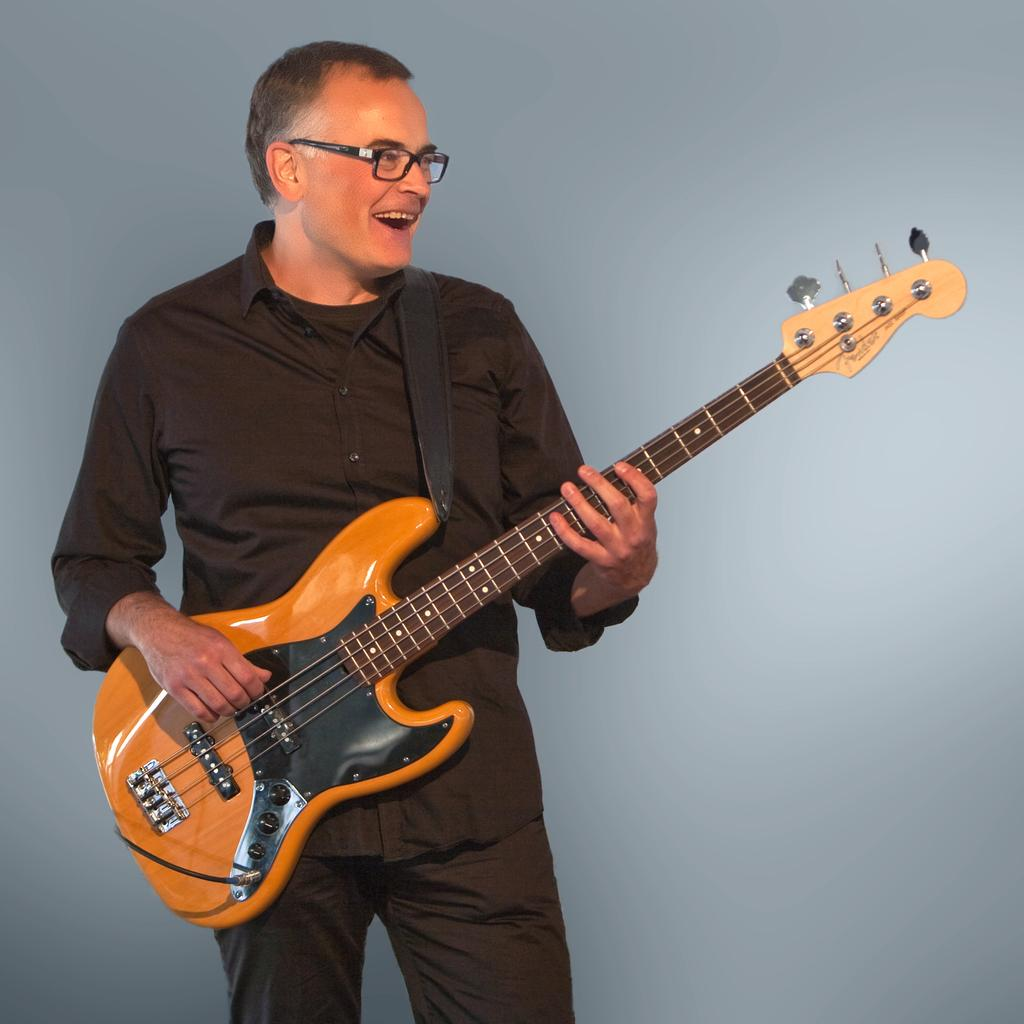What is the man in the image doing? The man is playing a guitar in the image. What is the man wearing? The man is wearing a black dress in the image. What color can be seen in the background of the image? There is a blue color in the background of the image. Can you see any oranges in the image? There are no oranges present in the image. Are there any nails visible in the image? There are no nails visible in the image. 